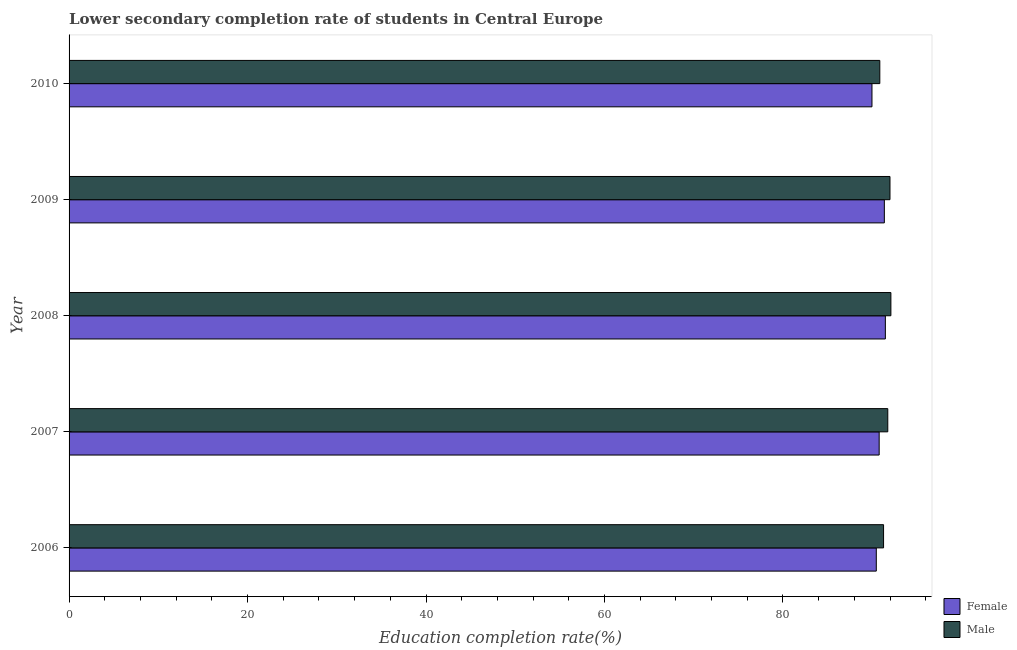How many groups of bars are there?
Keep it short and to the point. 5. How many bars are there on the 4th tick from the bottom?
Your answer should be very brief. 2. What is the label of the 5th group of bars from the top?
Provide a succinct answer. 2006. In how many cases, is the number of bars for a given year not equal to the number of legend labels?
Make the answer very short. 0. What is the education completion rate of female students in 2006?
Provide a short and direct response. 90.46. Across all years, what is the maximum education completion rate of female students?
Make the answer very short. 91.48. Across all years, what is the minimum education completion rate of female students?
Your response must be concise. 89.98. In which year was the education completion rate of female students minimum?
Offer a very short reply. 2010. What is the total education completion rate of male students in the graph?
Offer a terse response. 457.96. What is the difference between the education completion rate of male students in 2009 and that in 2010?
Make the answer very short. 1.14. What is the difference between the education completion rate of female students in 2008 and the education completion rate of male students in 2006?
Your answer should be compact. 0.2. What is the average education completion rate of female students per year?
Make the answer very short. 90.81. In the year 2006, what is the difference between the education completion rate of female students and education completion rate of male students?
Give a very brief answer. -0.81. Is the education completion rate of female students in 2006 less than that in 2009?
Provide a short and direct response. Yes. What is the difference between the highest and the second highest education completion rate of male students?
Provide a succinct answer. 0.1. What is the difference between the highest and the lowest education completion rate of male students?
Your answer should be very brief. 1.24. Is the sum of the education completion rate of female students in 2006 and 2008 greater than the maximum education completion rate of male students across all years?
Make the answer very short. Yes. What does the 2nd bar from the bottom in 2007 represents?
Offer a very short reply. Male. How many bars are there?
Keep it short and to the point. 10. Are all the bars in the graph horizontal?
Provide a short and direct response. Yes. Does the graph contain any zero values?
Your response must be concise. No. What is the title of the graph?
Offer a very short reply. Lower secondary completion rate of students in Central Europe. Does "Non-residents" appear as one of the legend labels in the graph?
Ensure brevity in your answer.  No. What is the label or title of the X-axis?
Offer a terse response. Education completion rate(%). What is the label or title of the Y-axis?
Your answer should be very brief. Year. What is the Education completion rate(%) in Female in 2006?
Provide a short and direct response. 90.46. What is the Education completion rate(%) of Male in 2006?
Your answer should be very brief. 91.27. What is the Education completion rate(%) in Female in 2007?
Provide a short and direct response. 90.78. What is the Education completion rate(%) in Male in 2007?
Offer a terse response. 91.75. What is the Education completion rate(%) of Female in 2008?
Your answer should be very brief. 91.48. What is the Education completion rate(%) in Male in 2008?
Provide a succinct answer. 92.1. What is the Education completion rate(%) of Female in 2009?
Your answer should be very brief. 91.36. What is the Education completion rate(%) of Male in 2009?
Provide a short and direct response. 91.99. What is the Education completion rate(%) in Female in 2010?
Provide a short and direct response. 89.98. What is the Education completion rate(%) in Male in 2010?
Make the answer very short. 90.85. Across all years, what is the maximum Education completion rate(%) of Female?
Make the answer very short. 91.48. Across all years, what is the maximum Education completion rate(%) of Male?
Provide a succinct answer. 92.1. Across all years, what is the minimum Education completion rate(%) in Female?
Offer a very short reply. 89.98. Across all years, what is the minimum Education completion rate(%) in Male?
Ensure brevity in your answer.  90.85. What is the total Education completion rate(%) in Female in the graph?
Make the answer very short. 454.06. What is the total Education completion rate(%) in Male in the graph?
Your answer should be compact. 457.96. What is the difference between the Education completion rate(%) of Female in 2006 and that in 2007?
Provide a succinct answer. -0.32. What is the difference between the Education completion rate(%) of Male in 2006 and that in 2007?
Make the answer very short. -0.47. What is the difference between the Education completion rate(%) in Female in 2006 and that in 2008?
Give a very brief answer. -1.02. What is the difference between the Education completion rate(%) of Male in 2006 and that in 2008?
Make the answer very short. -0.82. What is the difference between the Education completion rate(%) of Female in 2006 and that in 2009?
Your answer should be very brief. -0.9. What is the difference between the Education completion rate(%) of Male in 2006 and that in 2009?
Your response must be concise. -0.72. What is the difference between the Education completion rate(%) of Female in 2006 and that in 2010?
Provide a short and direct response. 0.49. What is the difference between the Education completion rate(%) of Male in 2006 and that in 2010?
Provide a short and direct response. 0.42. What is the difference between the Education completion rate(%) in Female in 2007 and that in 2008?
Provide a succinct answer. -0.69. What is the difference between the Education completion rate(%) in Male in 2007 and that in 2008?
Offer a terse response. -0.35. What is the difference between the Education completion rate(%) of Female in 2007 and that in 2009?
Provide a succinct answer. -0.58. What is the difference between the Education completion rate(%) of Male in 2007 and that in 2009?
Keep it short and to the point. -0.25. What is the difference between the Education completion rate(%) of Female in 2007 and that in 2010?
Ensure brevity in your answer.  0.81. What is the difference between the Education completion rate(%) of Male in 2007 and that in 2010?
Your answer should be compact. 0.89. What is the difference between the Education completion rate(%) in Female in 2008 and that in 2009?
Give a very brief answer. 0.11. What is the difference between the Education completion rate(%) in Male in 2008 and that in 2009?
Ensure brevity in your answer.  0.1. What is the difference between the Education completion rate(%) in Female in 2008 and that in 2010?
Give a very brief answer. 1.5. What is the difference between the Education completion rate(%) of Male in 2008 and that in 2010?
Give a very brief answer. 1.24. What is the difference between the Education completion rate(%) of Female in 2009 and that in 2010?
Keep it short and to the point. 1.39. What is the difference between the Education completion rate(%) of Male in 2009 and that in 2010?
Your response must be concise. 1.14. What is the difference between the Education completion rate(%) of Female in 2006 and the Education completion rate(%) of Male in 2007?
Keep it short and to the point. -1.29. What is the difference between the Education completion rate(%) in Female in 2006 and the Education completion rate(%) in Male in 2008?
Your response must be concise. -1.63. What is the difference between the Education completion rate(%) in Female in 2006 and the Education completion rate(%) in Male in 2009?
Give a very brief answer. -1.53. What is the difference between the Education completion rate(%) of Female in 2006 and the Education completion rate(%) of Male in 2010?
Make the answer very short. -0.39. What is the difference between the Education completion rate(%) of Female in 2007 and the Education completion rate(%) of Male in 2008?
Keep it short and to the point. -1.31. What is the difference between the Education completion rate(%) in Female in 2007 and the Education completion rate(%) in Male in 2009?
Provide a succinct answer. -1.21. What is the difference between the Education completion rate(%) in Female in 2007 and the Education completion rate(%) in Male in 2010?
Give a very brief answer. -0.07. What is the difference between the Education completion rate(%) in Female in 2008 and the Education completion rate(%) in Male in 2009?
Give a very brief answer. -0.52. What is the difference between the Education completion rate(%) in Female in 2008 and the Education completion rate(%) in Male in 2010?
Your answer should be compact. 0.62. What is the difference between the Education completion rate(%) in Female in 2009 and the Education completion rate(%) in Male in 2010?
Offer a very short reply. 0.51. What is the average Education completion rate(%) in Female per year?
Provide a short and direct response. 90.81. What is the average Education completion rate(%) in Male per year?
Your response must be concise. 91.59. In the year 2006, what is the difference between the Education completion rate(%) in Female and Education completion rate(%) in Male?
Your answer should be compact. -0.81. In the year 2007, what is the difference between the Education completion rate(%) of Female and Education completion rate(%) of Male?
Offer a terse response. -0.97. In the year 2008, what is the difference between the Education completion rate(%) in Female and Education completion rate(%) in Male?
Provide a short and direct response. -0.62. In the year 2009, what is the difference between the Education completion rate(%) of Female and Education completion rate(%) of Male?
Your answer should be compact. -0.63. In the year 2010, what is the difference between the Education completion rate(%) of Female and Education completion rate(%) of Male?
Provide a short and direct response. -0.88. What is the ratio of the Education completion rate(%) of Male in 2006 to that in 2007?
Your answer should be compact. 0.99. What is the ratio of the Education completion rate(%) of Female in 2006 to that in 2008?
Make the answer very short. 0.99. What is the ratio of the Education completion rate(%) of Male in 2006 to that in 2008?
Provide a succinct answer. 0.99. What is the ratio of the Education completion rate(%) of Female in 2006 to that in 2009?
Offer a terse response. 0.99. What is the ratio of the Education completion rate(%) in Female in 2006 to that in 2010?
Your answer should be very brief. 1.01. What is the ratio of the Education completion rate(%) in Female in 2007 to that in 2008?
Keep it short and to the point. 0.99. What is the ratio of the Education completion rate(%) in Male in 2007 to that in 2008?
Give a very brief answer. 1. What is the ratio of the Education completion rate(%) in Male in 2007 to that in 2009?
Provide a succinct answer. 1. What is the ratio of the Education completion rate(%) in Female in 2007 to that in 2010?
Provide a succinct answer. 1.01. What is the ratio of the Education completion rate(%) in Male in 2007 to that in 2010?
Your answer should be compact. 1.01. What is the ratio of the Education completion rate(%) of Female in 2008 to that in 2009?
Your response must be concise. 1. What is the ratio of the Education completion rate(%) of Male in 2008 to that in 2009?
Keep it short and to the point. 1. What is the ratio of the Education completion rate(%) of Female in 2008 to that in 2010?
Offer a terse response. 1.02. What is the ratio of the Education completion rate(%) in Male in 2008 to that in 2010?
Your answer should be very brief. 1.01. What is the ratio of the Education completion rate(%) of Female in 2009 to that in 2010?
Provide a succinct answer. 1.02. What is the ratio of the Education completion rate(%) in Male in 2009 to that in 2010?
Ensure brevity in your answer.  1.01. What is the difference between the highest and the second highest Education completion rate(%) in Female?
Make the answer very short. 0.11. What is the difference between the highest and the second highest Education completion rate(%) of Male?
Your answer should be compact. 0.1. What is the difference between the highest and the lowest Education completion rate(%) of Female?
Your answer should be compact. 1.5. What is the difference between the highest and the lowest Education completion rate(%) of Male?
Offer a very short reply. 1.24. 